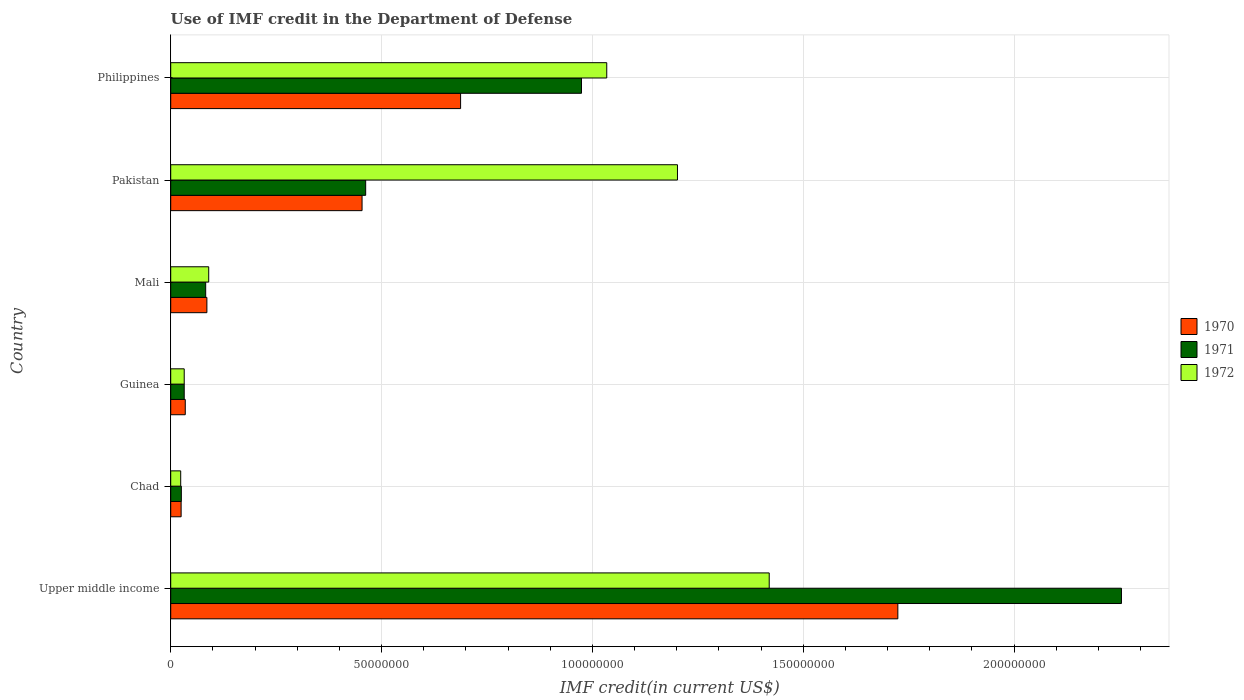How many groups of bars are there?
Your response must be concise. 6. Are the number of bars per tick equal to the number of legend labels?
Provide a succinct answer. Yes. Are the number of bars on each tick of the Y-axis equal?
Make the answer very short. Yes. What is the label of the 6th group of bars from the top?
Your answer should be compact. Upper middle income. What is the IMF credit in the Department of Defense in 1972 in Mali?
Keep it short and to the point. 9.01e+06. Across all countries, what is the maximum IMF credit in the Department of Defense in 1972?
Your answer should be very brief. 1.42e+08. Across all countries, what is the minimum IMF credit in the Department of Defense in 1972?
Offer a terse response. 2.37e+06. In which country was the IMF credit in the Department of Defense in 1970 maximum?
Keep it short and to the point. Upper middle income. In which country was the IMF credit in the Department of Defense in 1971 minimum?
Your response must be concise. Chad. What is the total IMF credit in the Department of Defense in 1970 in the graph?
Give a very brief answer. 3.01e+08. What is the difference between the IMF credit in the Department of Defense in 1970 in Mali and that in Pakistan?
Your response must be concise. -3.68e+07. What is the difference between the IMF credit in the Department of Defense in 1971 in Upper middle income and the IMF credit in the Department of Defense in 1970 in Pakistan?
Your response must be concise. 1.80e+08. What is the average IMF credit in the Department of Defense in 1971 per country?
Offer a terse response. 6.39e+07. What is the difference between the IMF credit in the Department of Defense in 1970 and IMF credit in the Department of Defense in 1971 in Chad?
Provide a short and direct response. -4.90e+04. In how many countries, is the IMF credit in the Department of Defense in 1972 greater than 170000000 US$?
Keep it short and to the point. 0. What is the ratio of the IMF credit in the Department of Defense in 1972 in Philippines to that in Upper middle income?
Provide a succinct answer. 0.73. What is the difference between the highest and the second highest IMF credit in the Department of Defense in 1972?
Ensure brevity in your answer.  2.18e+07. What is the difference between the highest and the lowest IMF credit in the Department of Defense in 1971?
Your answer should be very brief. 2.23e+08. In how many countries, is the IMF credit in the Department of Defense in 1970 greater than the average IMF credit in the Department of Defense in 1970 taken over all countries?
Provide a short and direct response. 2. Is it the case that in every country, the sum of the IMF credit in the Department of Defense in 1970 and IMF credit in the Department of Defense in 1971 is greater than the IMF credit in the Department of Defense in 1972?
Keep it short and to the point. No. How many bars are there?
Provide a succinct answer. 18. What is the difference between two consecutive major ticks on the X-axis?
Your answer should be compact. 5.00e+07. Does the graph contain any zero values?
Provide a short and direct response. No. Does the graph contain grids?
Your answer should be compact. Yes. How many legend labels are there?
Your answer should be very brief. 3. What is the title of the graph?
Provide a short and direct response. Use of IMF credit in the Department of Defense. What is the label or title of the X-axis?
Offer a terse response. IMF credit(in current US$). What is the label or title of the Y-axis?
Your answer should be very brief. Country. What is the IMF credit(in current US$) of 1970 in Upper middle income?
Provide a succinct answer. 1.72e+08. What is the IMF credit(in current US$) of 1971 in Upper middle income?
Provide a succinct answer. 2.25e+08. What is the IMF credit(in current US$) of 1972 in Upper middle income?
Offer a terse response. 1.42e+08. What is the IMF credit(in current US$) of 1970 in Chad?
Offer a very short reply. 2.47e+06. What is the IMF credit(in current US$) of 1971 in Chad?
Your response must be concise. 2.52e+06. What is the IMF credit(in current US$) of 1972 in Chad?
Your response must be concise. 2.37e+06. What is the IMF credit(in current US$) of 1970 in Guinea?
Your response must be concise. 3.45e+06. What is the IMF credit(in current US$) in 1971 in Guinea?
Provide a short and direct response. 3.20e+06. What is the IMF credit(in current US$) in 1972 in Guinea?
Your answer should be compact. 3.20e+06. What is the IMF credit(in current US$) of 1970 in Mali?
Your answer should be compact. 8.58e+06. What is the IMF credit(in current US$) in 1971 in Mali?
Ensure brevity in your answer.  8.30e+06. What is the IMF credit(in current US$) of 1972 in Mali?
Offer a terse response. 9.01e+06. What is the IMF credit(in current US$) of 1970 in Pakistan?
Your answer should be compact. 4.54e+07. What is the IMF credit(in current US$) of 1971 in Pakistan?
Give a very brief answer. 4.62e+07. What is the IMF credit(in current US$) of 1972 in Pakistan?
Provide a succinct answer. 1.20e+08. What is the IMF credit(in current US$) in 1970 in Philippines?
Provide a short and direct response. 6.88e+07. What is the IMF credit(in current US$) of 1971 in Philippines?
Provide a succinct answer. 9.74e+07. What is the IMF credit(in current US$) in 1972 in Philippines?
Give a very brief answer. 1.03e+08. Across all countries, what is the maximum IMF credit(in current US$) in 1970?
Offer a very short reply. 1.72e+08. Across all countries, what is the maximum IMF credit(in current US$) of 1971?
Offer a very short reply. 2.25e+08. Across all countries, what is the maximum IMF credit(in current US$) of 1972?
Your answer should be very brief. 1.42e+08. Across all countries, what is the minimum IMF credit(in current US$) of 1970?
Provide a short and direct response. 2.47e+06. Across all countries, what is the minimum IMF credit(in current US$) in 1971?
Make the answer very short. 2.52e+06. Across all countries, what is the minimum IMF credit(in current US$) in 1972?
Provide a succinct answer. 2.37e+06. What is the total IMF credit(in current US$) in 1970 in the graph?
Provide a succinct answer. 3.01e+08. What is the total IMF credit(in current US$) in 1971 in the graph?
Give a very brief answer. 3.83e+08. What is the total IMF credit(in current US$) of 1972 in the graph?
Offer a very short reply. 3.80e+08. What is the difference between the IMF credit(in current US$) in 1970 in Upper middle income and that in Chad?
Your answer should be very brief. 1.70e+08. What is the difference between the IMF credit(in current US$) in 1971 in Upper middle income and that in Chad?
Offer a very short reply. 2.23e+08. What is the difference between the IMF credit(in current US$) in 1972 in Upper middle income and that in Chad?
Your response must be concise. 1.40e+08. What is the difference between the IMF credit(in current US$) in 1970 in Upper middle income and that in Guinea?
Give a very brief answer. 1.69e+08. What is the difference between the IMF credit(in current US$) of 1971 in Upper middle income and that in Guinea?
Ensure brevity in your answer.  2.22e+08. What is the difference between the IMF credit(in current US$) in 1972 in Upper middle income and that in Guinea?
Offer a very short reply. 1.39e+08. What is the difference between the IMF credit(in current US$) in 1970 in Upper middle income and that in Mali?
Offer a very short reply. 1.64e+08. What is the difference between the IMF credit(in current US$) of 1971 in Upper middle income and that in Mali?
Your response must be concise. 2.17e+08. What is the difference between the IMF credit(in current US$) of 1972 in Upper middle income and that in Mali?
Offer a terse response. 1.33e+08. What is the difference between the IMF credit(in current US$) in 1970 in Upper middle income and that in Pakistan?
Provide a succinct answer. 1.27e+08. What is the difference between the IMF credit(in current US$) of 1971 in Upper middle income and that in Pakistan?
Give a very brief answer. 1.79e+08. What is the difference between the IMF credit(in current US$) in 1972 in Upper middle income and that in Pakistan?
Give a very brief answer. 2.18e+07. What is the difference between the IMF credit(in current US$) of 1970 in Upper middle income and that in Philippines?
Keep it short and to the point. 1.04e+08. What is the difference between the IMF credit(in current US$) in 1971 in Upper middle income and that in Philippines?
Offer a terse response. 1.28e+08. What is the difference between the IMF credit(in current US$) in 1972 in Upper middle income and that in Philippines?
Provide a succinct answer. 3.85e+07. What is the difference between the IMF credit(in current US$) of 1970 in Chad and that in Guinea?
Provide a succinct answer. -9.80e+05. What is the difference between the IMF credit(in current US$) in 1971 in Chad and that in Guinea?
Offer a terse response. -6.84e+05. What is the difference between the IMF credit(in current US$) of 1972 in Chad and that in Guinea?
Your answer should be compact. -8.36e+05. What is the difference between the IMF credit(in current US$) in 1970 in Chad and that in Mali?
Offer a terse response. -6.11e+06. What is the difference between the IMF credit(in current US$) of 1971 in Chad and that in Mali?
Make the answer very short. -5.78e+06. What is the difference between the IMF credit(in current US$) of 1972 in Chad and that in Mali?
Keep it short and to the point. -6.64e+06. What is the difference between the IMF credit(in current US$) in 1970 in Chad and that in Pakistan?
Your answer should be very brief. -4.29e+07. What is the difference between the IMF credit(in current US$) in 1971 in Chad and that in Pakistan?
Make the answer very short. -4.37e+07. What is the difference between the IMF credit(in current US$) of 1972 in Chad and that in Pakistan?
Your answer should be compact. -1.18e+08. What is the difference between the IMF credit(in current US$) in 1970 in Chad and that in Philippines?
Provide a succinct answer. -6.63e+07. What is the difference between the IMF credit(in current US$) of 1971 in Chad and that in Philippines?
Your answer should be compact. -9.49e+07. What is the difference between the IMF credit(in current US$) of 1972 in Chad and that in Philippines?
Make the answer very short. -1.01e+08. What is the difference between the IMF credit(in current US$) in 1970 in Guinea and that in Mali?
Your answer should be very brief. -5.13e+06. What is the difference between the IMF credit(in current US$) of 1971 in Guinea and that in Mali?
Your response must be concise. -5.09e+06. What is the difference between the IMF credit(in current US$) of 1972 in Guinea and that in Mali?
Your answer should be compact. -5.81e+06. What is the difference between the IMF credit(in current US$) of 1970 in Guinea and that in Pakistan?
Your answer should be compact. -4.19e+07. What is the difference between the IMF credit(in current US$) in 1971 in Guinea and that in Pakistan?
Offer a very short reply. -4.30e+07. What is the difference between the IMF credit(in current US$) of 1972 in Guinea and that in Pakistan?
Offer a terse response. -1.17e+08. What is the difference between the IMF credit(in current US$) of 1970 in Guinea and that in Philippines?
Provide a short and direct response. -6.53e+07. What is the difference between the IMF credit(in current US$) in 1971 in Guinea and that in Philippines?
Offer a terse response. -9.42e+07. What is the difference between the IMF credit(in current US$) of 1972 in Guinea and that in Philippines?
Offer a terse response. -1.00e+08. What is the difference between the IMF credit(in current US$) of 1970 in Mali and that in Pakistan?
Provide a short and direct response. -3.68e+07. What is the difference between the IMF credit(in current US$) in 1971 in Mali and that in Pakistan?
Offer a terse response. -3.79e+07. What is the difference between the IMF credit(in current US$) of 1972 in Mali and that in Pakistan?
Provide a succinct answer. -1.11e+08. What is the difference between the IMF credit(in current US$) in 1970 in Mali and that in Philippines?
Give a very brief answer. -6.02e+07. What is the difference between the IMF credit(in current US$) in 1971 in Mali and that in Philippines?
Your response must be concise. -8.91e+07. What is the difference between the IMF credit(in current US$) of 1972 in Mali and that in Philippines?
Offer a very short reply. -9.44e+07. What is the difference between the IMF credit(in current US$) in 1970 in Pakistan and that in Philippines?
Your answer should be compact. -2.34e+07. What is the difference between the IMF credit(in current US$) in 1971 in Pakistan and that in Philippines?
Make the answer very short. -5.12e+07. What is the difference between the IMF credit(in current US$) of 1972 in Pakistan and that in Philippines?
Offer a terse response. 1.68e+07. What is the difference between the IMF credit(in current US$) of 1970 in Upper middle income and the IMF credit(in current US$) of 1971 in Chad?
Give a very brief answer. 1.70e+08. What is the difference between the IMF credit(in current US$) in 1970 in Upper middle income and the IMF credit(in current US$) in 1972 in Chad?
Your response must be concise. 1.70e+08. What is the difference between the IMF credit(in current US$) of 1971 in Upper middle income and the IMF credit(in current US$) of 1972 in Chad?
Offer a terse response. 2.23e+08. What is the difference between the IMF credit(in current US$) of 1970 in Upper middle income and the IMF credit(in current US$) of 1971 in Guinea?
Your answer should be compact. 1.69e+08. What is the difference between the IMF credit(in current US$) of 1970 in Upper middle income and the IMF credit(in current US$) of 1972 in Guinea?
Provide a succinct answer. 1.69e+08. What is the difference between the IMF credit(in current US$) of 1971 in Upper middle income and the IMF credit(in current US$) of 1972 in Guinea?
Make the answer very short. 2.22e+08. What is the difference between the IMF credit(in current US$) in 1970 in Upper middle income and the IMF credit(in current US$) in 1971 in Mali?
Ensure brevity in your answer.  1.64e+08. What is the difference between the IMF credit(in current US$) in 1970 in Upper middle income and the IMF credit(in current US$) in 1972 in Mali?
Make the answer very short. 1.63e+08. What is the difference between the IMF credit(in current US$) in 1971 in Upper middle income and the IMF credit(in current US$) in 1972 in Mali?
Your answer should be very brief. 2.16e+08. What is the difference between the IMF credit(in current US$) in 1970 in Upper middle income and the IMF credit(in current US$) in 1971 in Pakistan?
Your response must be concise. 1.26e+08. What is the difference between the IMF credit(in current US$) in 1970 in Upper middle income and the IMF credit(in current US$) in 1972 in Pakistan?
Ensure brevity in your answer.  5.23e+07. What is the difference between the IMF credit(in current US$) in 1971 in Upper middle income and the IMF credit(in current US$) in 1972 in Pakistan?
Offer a terse response. 1.05e+08. What is the difference between the IMF credit(in current US$) of 1970 in Upper middle income and the IMF credit(in current US$) of 1971 in Philippines?
Give a very brief answer. 7.50e+07. What is the difference between the IMF credit(in current US$) in 1970 in Upper middle income and the IMF credit(in current US$) in 1972 in Philippines?
Ensure brevity in your answer.  6.90e+07. What is the difference between the IMF credit(in current US$) in 1971 in Upper middle income and the IMF credit(in current US$) in 1972 in Philippines?
Ensure brevity in your answer.  1.22e+08. What is the difference between the IMF credit(in current US$) in 1970 in Chad and the IMF credit(in current US$) in 1971 in Guinea?
Your answer should be very brief. -7.33e+05. What is the difference between the IMF credit(in current US$) in 1970 in Chad and the IMF credit(in current US$) in 1972 in Guinea?
Provide a short and direct response. -7.33e+05. What is the difference between the IMF credit(in current US$) of 1971 in Chad and the IMF credit(in current US$) of 1972 in Guinea?
Offer a terse response. -6.84e+05. What is the difference between the IMF credit(in current US$) in 1970 in Chad and the IMF credit(in current US$) in 1971 in Mali?
Your response must be concise. -5.82e+06. What is the difference between the IMF credit(in current US$) in 1970 in Chad and the IMF credit(in current US$) in 1972 in Mali?
Offer a very short reply. -6.54e+06. What is the difference between the IMF credit(in current US$) in 1971 in Chad and the IMF credit(in current US$) in 1972 in Mali?
Your answer should be compact. -6.49e+06. What is the difference between the IMF credit(in current US$) in 1970 in Chad and the IMF credit(in current US$) in 1971 in Pakistan?
Provide a succinct answer. -4.38e+07. What is the difference between the IMF credit(in current US$) in 1970 in Chad and the IMF credit(in current US$) in 1972 in Pakistan?
Provide a short and direct response. -1.18e+08. What is the difference between the IMF credit(in current US$) in 1971 in Chad and the IMF credit(in current US$) in 1972 in Pakistan?
Ensure brevity in your answer.  -1.18e+08. What is the difference between the IMF credit(in current US$) of 1970 in Chad and the IMF credit(in current US$) of 1971 in Philippines?
Your answer should be compact. -9.50e+07. What is the difference between the IMF credit(in current US$) of 1970 in Chad and the IMF credit(in current US$) of 1972 in Philippines?
Provide a succinct answer. -1.01e+08. What is the difference between the IMF credit(in current US$) of 1971 in Chad and the IMF credit(in current US$) of 1972 in Philippines?
Your response must be concise. -1.01e+08. What is the difference between the IMF credit(in current US$) of 1970 in Guinea and the IMF credit(in current US$) of 1971 in Mali?
Your response must be concise. -4.84e+06. What is the difference between the IMF credit(in current US$) in 1970 in Guinea and the IMF credit(in current US$) in 1972 in Mali?
Your answer should be compact. -5.56e+06. What is the difference between the IMF credit(in current US$) in 1971 in Guinea and the IMF credit(in current US$) in 1972 in Mali?
Offer a terse response. -5.81e+06. What is the difference between the IMF credit(in current US$) in 1970 in Guinea and the IMF credit(in current US$) in 1971 in Pakistan?
Provide a short and direct response. -4.28e+07. What is the difference between the IMF credit(in current US$) in 1970 in Guinea and the IMF credit(in current US$) in 1972 in Pakistan?
Your answer should be very brief. -1.17e+08. What is the difference between the IMF credit(in current US$) of 1971 in Guinea and the IMF credit(in current US$) of 1972 in Pakistan?
Keep it short and to the point. -1.17e+08. What is the difference between the IMF credit(in current US$) in 1970 in Guinea and the IMF credit(in current US$) in 1971 in Philippines?
Keep it short and to the point. -9.40e+07. What is the difference between the IMF credit(in current US$) of 1970 in Guinea and the IMF credit(in current US$) of 1972 in Philippines?
Offer a terse response. -1.00e+08. What is the difference between the IMF credit(in current US$) in 1971 in Guinea and the IMF credit(in current US$) in 1972 in Philippines?
Ensure brevity in your answer.  -1.00e+08. What is the difference between the IMF credit(in current US$) in 1970 in Mali and the IMF credit(in current US$) in 1971 in Pakistan?
Make the answer very short. -3.77e+07. What is the difference between the IMF credit(in current US$) of 1970 in Mali and the IMF credit(in current US$) of 1972 in Pakistan?
Make the answer very short. -1.12e+08. What is the difference between the IMF credit(in current US$) of 1971 in Mali and the IMF credit(in current US$) of 1972 in Pakistan?
Offer a terse response. -1.12e+08. What is the difference between the IMF credit(in current US$) in 1970 in Mali and the IMF credit(in current US$) in 1971 in Philippines?
Make the answer very short. -8.88e+07. What is the difference between the IMF credit(in current US$) of 1970 in Mali and the IMF credit(in current US$) of 1972 in Philippines?
Offer a terse response. -9.48e+07. What is the difference between the IMF credit(in current US$) of 1971 in Mali and the IMF credit(in current US$) of 1972 in Philippines?
Make the answer very short. -9.51e+07. What is the difference between the IMF credit(in current US$) of 1970 in Pakistan and the IMF credit(in current US$) of 1971 in Philippines?
Provide a succinct answer. -5.20e+07. What is the difference between the IMF credit(in current US$) in 1970 in Pakistan and the IMF credit(in current US$) in 1972 in Philippines?
Your answer should be very brief. -5.80e+07. What is the difference between the IMF credit(in current US$) in 1971 in Pakistan and the IMF credit(in current US$) in 1972 in Philippines?
Offer a very short reply. -5.72e+07. What is the average IMF credit(in current US$) of 1970 per country?
Ensure brevity in your answer.  5.02e+07. What is the average IMF credit(in current US$) in 1971 per country?
Ensure brevity in your answer.  6.39e+07. What is the average IMF credit(in current US$) in 1972 per country?
Offer a very short reply. 6.34e+07. What is the difference between the IMF credit(in current US$) in 1970 and IMF credit(in current US$) in 1971 in Upper middle income?
Your answer should be very brief. -5.30e+07. What is the difference between the IMF credit(in current US$) of 1970 and IMF credit(in current US$) of 1972 in Upper middle income?
Keep it short and to the point. 3.05e+07. What is the difference between the IMF credit(in current US$) of 1971 and IMF credit(in current US$) of 1972 in Upper middle income?
Offer a terse response. 8.35e+07. What is the difference between the IMF credit(in current US$) in 1970 and IMF credit(in current US$) in 1971 in Chad?
Keep it short and to the point. -4.90e+04. What is the difference between the IMF credit(in current US$) in 1970 and IMF credit(in current US$) in 1972 in Chad?
Your answer should be compact. 1.03e+05. What is the difference between the IMF credit(in current US$) of 1971 and IMF credit(in current US$) of 1972 in Chad?
Your answer should be compact. 1.52e+05. What is the difference between the IMF credit(in current US$) of 1970 and IMF credit(in current US$) of 1971 in Guinea?
Offer a terse response. 2.47e+05. What is the difference between the IMF credit(in current US$) of 1970 and IMF credit(in current US$) of 1972 in Guinea?
Keep it short and to the point. 2.47e+05. What is the difference between the IMF credit(in current US$) in 1971 and IMF credit(in current US$) in 1972 in Guinea?
Your response must be concise. 0. What is the difference between the IMF credit(in current US$) of 1970 and IMF credit(in current US$) of 1971 in Mali?
Make the answer very short. 2.85e+05. What is the difference between the IMF credit(in current US$) of 1970 and IMF credit(in current US$) of 1972 in Mali?
Give a very brief answer. -4.31e+05. What is the difference between the IMF credit(in current US$) of 1971 and IMF credit(in current US$) of 1972 in Mali?
Your answer should be compact. -7.16e+05. What is the difference between the IMF credit(in current US$) in 1970 and IMF credit(in current US$) in 1971 in Pakistan?
Provide a short and direct response. -8.56e+05. What is the difference between the IMF credit(in current US$) of 1970 and IMF credit(in current US$) of 1972 in Pakistan?
Your response must be concise. -7.48e+07. What is the difference between the IMF credit(in current US$) of 1971 and IMF credit(in current US$) of 1972 in Pakistan?
Give a very brief answer. -7.40e+07. What is the difference between the IMF credit(in current US$) in 1970 and IMF credit(in current US$) in 1971 in Philippines?
Keep it short and to the point. -2.87e+07. What is the difference between the IMF credit(in current US$) of 1970 and IMF credit(in current US$) of 1972 in Philippines?
Keep it short and to the point. -3.47e+07. What is the difference between the IMF credit(in current US$) in 1971 and IMF credit(in current US$) in 1972 in Philippines?
Provide a short and direct response. -5.99e+06. What is the ratio of the IMF credit(in current US$) of 1970 in Upper middle income to that in Chad?
Keep it short and to the point. 69.82. What is the ratio of the IMF credit(in current US$) in 1971 in Upper middle income to that in Chad?
Your answer should be compact. 89.51. What is the ratio of the IMF credit(in current US$) in 1972 in Upper middle income to that in Chad?
Give a very brief answer. 59.97. What is the ratio of the IMF credit(in current US$) in 1970 in Upper middle income to that in Guinea?
Your answer should be very brief. 49.99. What is the ratio of the IMF credit(in current US$) in 1971 in Upper middle income to that in Guinea?
Provide a short and direct response. 70.4. What is the ratio of the IMF credit(in current US$) in 1972 in Upper middle income to that in Guinea?
Your answer should be compact. 44.32. What is the ratio of the IMF credit(in current US$) of 1970 in Upper middle income to that in Mali?
Make the answer very short. 20.1. What is the ratio of the IMF credit(in current US$) in 1971 in Upper middle income to that in Mali?
Ensure brevity in your answer.  27.18. What is the ratio of the IMF credit(in current US$) in 1972 in Upper middle income to that in Mali?
Your answer should be compact. 15.75. What is the ratio of the IMF credit(in current US$) in 1970 in Upper middle income to that in Pakistan?
Make the answer very short. 3.8. What is the ratio of the IMF credit(in current US$) of 1971 in Upper middle income to that in Pakistan?
Provide a short and direct response. 4.88. What is the ratio of the IMF credit(in current US$) of 1972 in Upper middle income to that in Pakistan?
Keep it short and to the point. 1.18. What is the ratio of the IMF credit(in current US$) in 1970 in Upper middle income to that in Philippines?
Offer a terse response. 2.51. What is the ratio of the IMF credit(in current US$) of 1971 in Upper middle income to that in Philippines?
Your response must be concise. 2.31. What is the ratio of the IMF credit(in current US$) of 1972 in Upper middle income to that in Philippines?
Ensure brevity in your answer.  1.37. What is the ratio of the IMF credit(in current US$) of 1970 in Chad to that in Guinea?
Your response must be concise. 0.72. What is the ratio of the IMF credit(in current US$) in 1971 in Chad to that in Guinea?
Give a very brief answer. 0.79. What is the ratio of the IMF credit(in current US$) in 1972 in Chad to that in Guinea?
Your answer should be compact. 0.74. What is the ratio of the IMF credit(in current US$) in 1970 in Chad to that in Mali?
Keep it short and to the point. 0.29. What is the ratio of the IMF credit(in current US$) in 1971 in Chad to that in Mali?
Provide a succinct answer. 0.3. What is the ratio of the IMF credit(in current US$) of 1972 in Chad to that in Mali?
Provide a succinct answer. 0.26. What is the ratio of the IMF credit(in current US$) of 1970 in Chad to that in Pakistan?
Your response must be concise. 0.05. What is the ratio of the IMF credit(in current US$) in 1971 in Chad to that in Pakistan?
Your answer should be compact. 0.05. What is the ratio of the IMF credit(in current US$) of 1972 in Chad to that in Pakistan?
Your answer should be compact. 0.02. What is the ratio of the IMF credit(in current US$) in 1970 in Chad to that in Philippines?
Provide a succinct answer. 0.04. What is the ratio of the IMF credit(in current US$) in 1971 in Chad to that in Philippines?
Keep it short and to the point. 0.03. What is the ratio of the IMF credit(in current US$) of 1972 in Chad to that in Philippines?
Your response must be concise. 0.02. What is the ratio of the IMF credit(in current US$) of 1970 in Guinea to that in Mali?
Make the answer very short. 0.4. What is the ratio of the IMF credit(in current US$) of 1971 in Guinea to that in Mali?
Provide a short and direct response. 0.39. What is the ratio of the IMF credit(in current US$) in 1972 in Guinea to that in Mali?
Your answer should be very brief. 0.36. What is the ratio of the IMF credit(in current US$) in 1970 in Guinea to that in Pakistan?
Give a very brief answer. 0.08. What is the ratio of the IMF credit(in current US$) of 1971 in Guinea to that in Pakistan?
Ensure brevity in your answer.  0.07. What is the ratio of the IMF credit(in current US$) in 1972 in Guinea to that in Pakistan?
Your response must be concise. 0.03. What is the ratio of the IMF credit(in current US$) in 1970 in Guinea to that in Philippines?
Keep it short and to the point. 0.05. What is the ratio of the IMF credit(in current US$) of 1971 in Guinea to that in Philippines?
Offer a terse response. 0.03. What is the ratio of the IMF credit(in current US$) in 1972 in Guinea to that in Philippines?
Your response must be concise. 0.03. What is the ratio of the IMF credit(in current US$) in 1970 in Mali to that in Pakistan?
Give a very brief answer. 0.19. What is the ratio of the IMF credit(in current US$) in 1971 in Mali to that in Pakistan?
Provide a short and direct response. 0.18. What is the ratio of the IMF credit(in current US$) of 1972 in Mali to that in Pakistan?
Your answer should be compact. 0.07. What is the ratio of the IMF credit(in current US$) of 1970 in Mali to that in Philippines?
Make the answer very short. 0.12. What is the ratio of the IMF credit(in current US$) in 1971 in Mali to that in Philippines?
Offer a very short reply. 0.09. What is the ratio of the IMF credit(in current US$) in 1972 in Mali to that in Philippines?
Keep it short and to the point. 0.09. What is the ratio of the IMF credit(in current US$) in 1970 in Pakistan to that in Philippines?
Offer a terse response. 0.66. What is the ratio of the IMF credit(in current US$) of 1971 in Pakistan to that in Philippines?
Make the answer very short. 0.47. What is the ratio of the IMF credit(in current US$) in 1972 in Pakistan to that in Philippines?
Make the answer very short. 1.16. What is the difference between the highest and the second highest IMF credit(in current US$) in 1970?
Provide a succinct answer. 1.04e+08. What is the difference between the highest and the second highest IMF credit(in current US$) of 1971?
Offer a very short reply. 1.28e+08. What is the difference between the highest and the second highest IMF credit(in current US$) of 1972?
Offer a terse response. 2.18e+07. What is the difference between the highest and the lowest IMF credit(in current US$) of 1970?
Offer a terse response. 1.70e+08. What is the difference between the highest and the lowest IMF credit(in current US$) of 1971?
Provide a short and direct response. 2.23e+08. What is the difference between the highest and the lowest IMF credit(in current US$) of 1972?
Make the answer very short. 1.40e+08. 